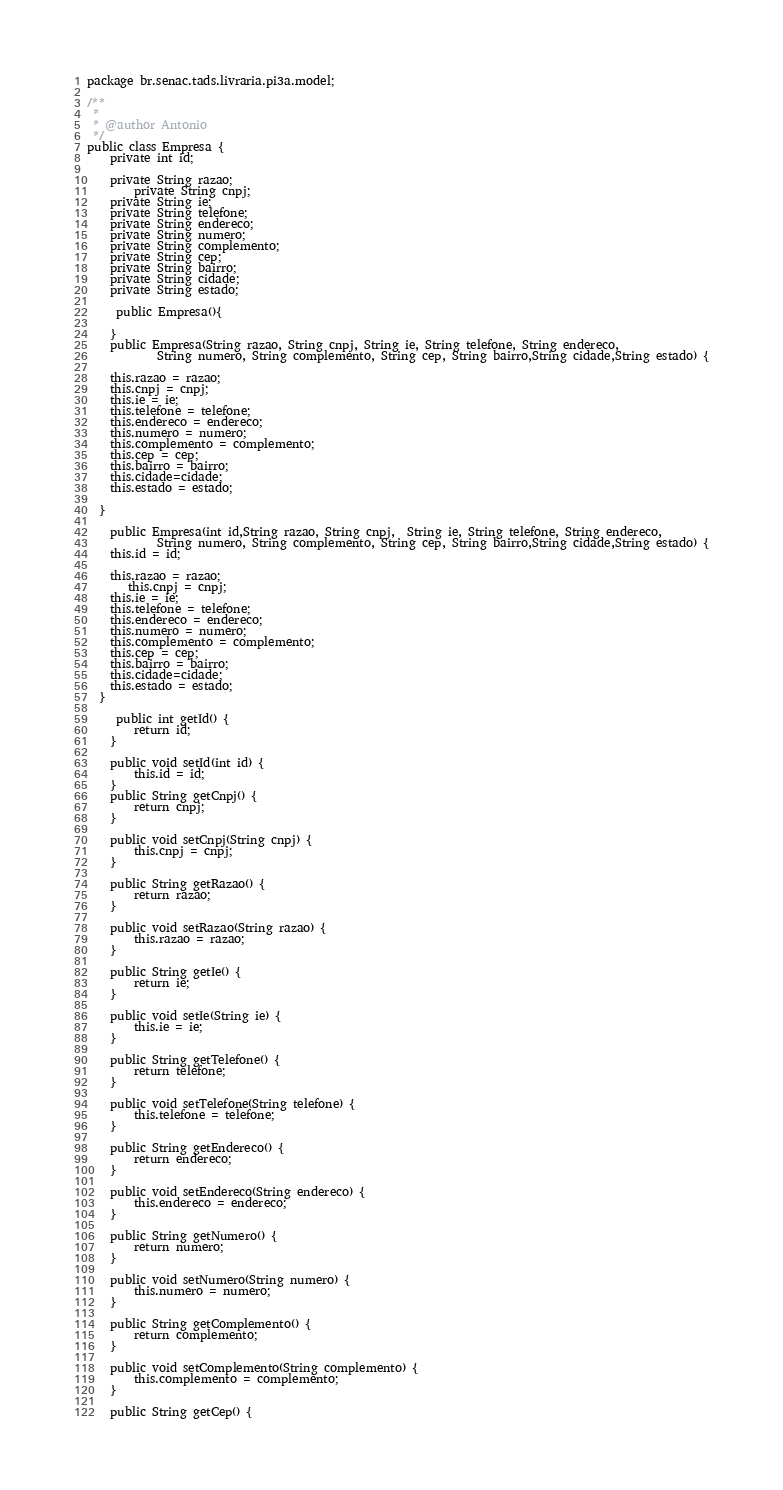<code> <loc_0><loc_0><loc_500><loc_500><_Java_>
package br.senac.tads.livraria.pi3a.model;

/**
 *
 * @author Antonio
 */
public class Empresa {
    private int id;

    private String razao;
        private String cnpj;
    private String ie;
    private String telefone;
    private String endereco;
    private String numero;
    private String complemento;
    private String cep;
    private String bairro;
    private String cidade;
    private String estado;
    
     public Empresa(){
        
    }
    public Empresa(String razao, String cnpj, String ie, String telefone, String endereco, 
            String numero, String complemento, String cep, String bairro,String cidade,String estado) {
    
    this.razao = razao;
    this.cnpj = cnpj;
    this.ie = ie;
    this.telefone = telefone;
    this.endereco = endereco;
    this.numero = numero;
    this.complemento = complemento;
    this.cep = cep;
    this.bairro = bairro;
    this.cidade=cidade;
    this.estado = estado;
    
  }
    
    public Empresa(int id,String razao, String cnpj,  String ie, String telefone, String endereco, 
            String numero, String complemento, String cep, String bairro,String cidade,String estado) {
    this.id = id;    
 
    this.razao = razao;
       this.cnpj = cnpj;
    this.ie = ie;
    this.telefone = telefone;
    this.endereco = endereco;
    this.numero = numero;
    this.complemento = complemento;
    this.cep = cep;
    this.bairro = bairro;
    this.cidade=cidade;
    this.estado = estado;
  }
    
     public int getId() {
        return id;
    }

    public void setId(int id) {
        this.id = id;
    }
    public String getCnpj() {
        return cnpj;
    }

    public void setCnpj(String cnpj) {
        this.cnpj = cnpj;
    }

    public String getRazao() {
        return razao;
    }

    public void setRazao(String razao) {
        this.razao = razao;
    }

    public String getIe() {
        return ie;
    }

    public void setIe(String ie) {
        this.ie = ie;
    }

    public String getTelefone() {
        return telefone;
    }

    public void setTelefone(String telefone) {
        this.telefone = telefone;
    }

    public String getEndereco() {
        return endereco;
    }

    public void setEndereco(String endereco) {
        this.endereco = endereco;
    }

    public String getNumero() {
        return numero;
    }

    public void setNumero(String numero) {
        this.numero = numero;
    }

    public String getComplemento() {
        return complemento;
    }

    public void setComplemento(String complemento) {
        this.complemento = complemento;
    }

    public String getCep() {</code> 